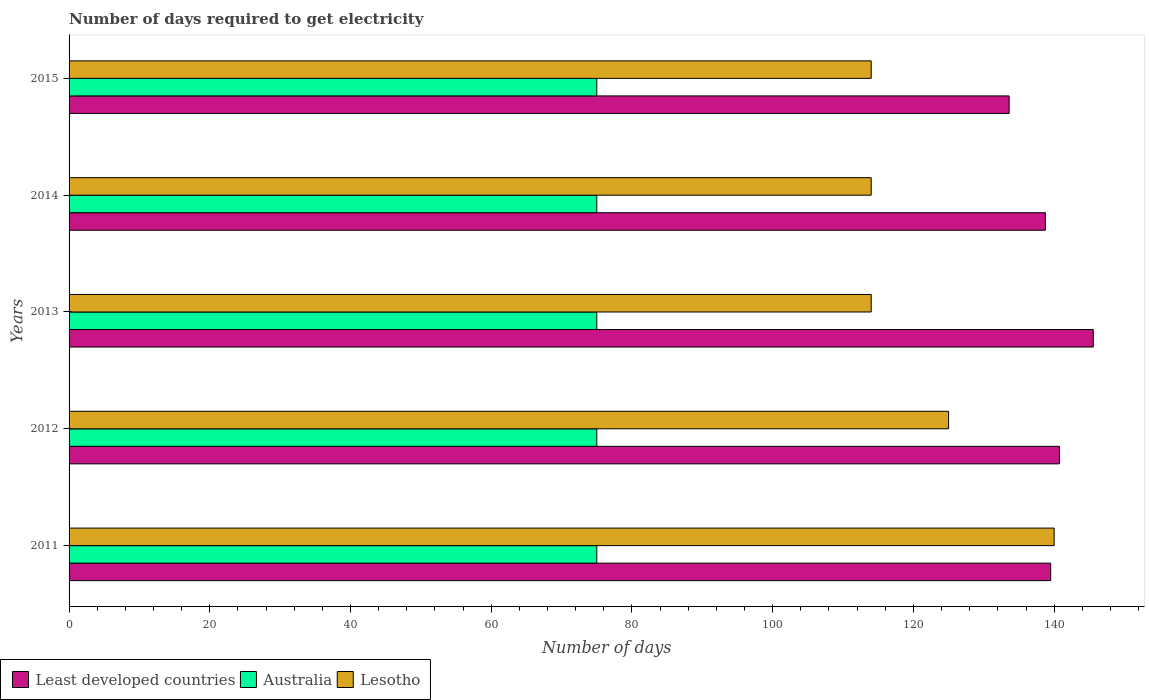How many different coloured bars are there?
Give a very brief answer. 3. Are the number of bars on each tick of the Y-axis equal?
Your response must be concise. Yes. How many bars are there on the 5th tick from the top?
Your answer should be compact. 3. How many bars are there on the 1st tick from the bottom?
Make the answer very short. 3. What is the label of the 4th group of bars from the top?
Keep it short and to the point. 2012. In how many cases, is the number of bars for a given year not equal to the number of legend labels?
Your answer should be very brief. 0. What is the number of days required to get electricity in in Australia in 2014?
Keep it short and to the point. 75. Across all years, what is the maximum number of days required to get electricity in in Lesotho?
Offer a terse response. 140. Across all years, what is the minimum number of days required to get electricity in in Least developed countries?
Your answer should be very brief. 133.61. In which year was the number of days required to get electricity in in Australia maximum?
Give a very brief answer. 2011. In which year was the number of days required to get electricity in in Least developed countries minimum?
Offer a very short reply. 2015. What is the total number of days required to get electricity in in Australia in the graph?
Give a very brief answer. 375. What is the difference between the number of days required to get electricity in in Australia in 2014 and the number of days required to get electricity in in Least developed countries in 2015?
Offer a terse response. -58.61. What is the average number of days required to get electricity in in Australia per year?
Provide a short and direct response. 75. In the year 2015, what is the difference between the number of days required to get electricity in in Australia and number of days required to get electricity in in Least developed countries?
Your answer should be very brief. -58.61. In how many years, is the number of days required to get electricity in in Lesotho greater than 88 days?
Offer a very short reply. 5. What is the difference between the highest and the second highest number of days required to get electricity in in Least developed countries?
Offer a terse response. 4.81. What is the difference between the highest and the lowest number of days required to get electricity in in Lesotho?
Your answer should be compact. 26. In how many years, is the number of days required to get electricity in in Lesotho greater than the average number of days required to get electricity in in Lesotho taken over all years?
Make the answer very short. 2. What does the 3rd bar from the top in 2012 represents?
Make the answer very short. Least developed countries. What does the 1st bar from the bottom in 2012 represents?
Offer a very short reply. Least developed countries. Are all the bars in the graph horizontal?
Give a very brief answer. Yes. What is the difference between two consecutive major ticks on the X-axis?
Give a very brief answer. 20. What is the title of the graph?
Provide a succinct answer. Number of days required to get electricity. What is the label or title of the X-axis?
Ensure brevity in your answer.  Number of days. What is the Number of days in Least developed countries in 2011?
Offer a very short reply. 139.51. What is the Number of days in Australia in 2011?
Offer a very short reply. 75. What is the Number of days in Lesotho in 2011?
Offer a very short reply. 140. What is the Number of days of Least developed countries in 2012?
Offer a terse response. 140.76. What is the Number of days of Australia in 2012?
Your answer should be very brief. 75. What is the Number of days of Lesotho in 2012?
Offer a terse response. 125. What is the Number of days of Least developed countries in 2013?
Provide a short and direct response. 145.56. What is the Number of days of Australia in 2013?
Give a very brief answer. 75. What is the Number of days of Lesotho in 2013?
Provide a succinct answer. 114. What is the Number of days of Least developed countries in 2014?
Offer a very short reply. 138.76. What is the Number of days in Lesotho in 2014?
Offer a terse response. 114. What is the Number of days of Least developed countries in 2015?
Make the answer very short. 133.61. What is the Number of days in Lesotho in 2015?
Provide a succinct answer. 114. Across all years, what is the maximum Number of days in Least developed countries?
Keep it short and to the point. 145.56. Across all years, what is the maximum Number of days of Australia?
Offer a very short reply. 75. Across all years, what is the maximum Number of days of Lesotho?
Provide a short and direct response. 140. Across all years, what is the minimum Number of days in Least developed countries?
Offer a terse response. 133.61. Across all years, what is the minimum Number of days in Lesotho?
Your answer should be very brief. 114. What is the total Number of days in Least developed countries in the graph?
Offer a terse response. 698.2. What is the total Number of days of Australia in the graph?
Your response must be concise. 375. What is the total Number of days in Lesotho in the graph?
Offer a very short reply. 607. What is the difference between the Number of days in Least developed countries in 2011 and that in 2012?
Your answer should be very brief. -1.24. What is the difference between the Number of days in Least developed countries in 2011 and that in 2013?
Provide a succinct answer. -6.05. What is the difference between the Number of days in Least developed countries in 2011 and that in 2014?
Ensure brevity in your answer.  0.75. What is the difference between the Number of days of Australia in 2011 and that in 2014?
Offer a terse response. 0. What is the difference between the Number of days of Least developed countries in 2011 and that in 2015?
Give a very brief answer. 5.91. What is the difference between the Number of days in Lesotho in 2011 and that in 2015?
Your response must be concise. 26. What is the difference between the Number of days in Least developed countries in 2012 and that in 2013?
Keep it short and to the point. -4.81. What is the difference between the Number of days in Australia in 2012 and that in 2013?
Provide a short and direct response. 0. What is the difference between the Number of days of Least developed countries in 2012 and that in 2014?
Your answer should be very brief. 2. What is the difference between the Number of days of Least developed countries in 2012 and that in 2015?
Your response must be concise. 7.15. What is the difference between the Number of days in Australia in 2012 and that in 2015?
Your answer should be compact. 0. What is the difference between the Number of days of Lesotho in 2012 and that in 2015?
Offer a terse response. 11. What is the difference between the Number of days in Least developed countries in 2013 and that in 2014?
Ensure brevity in your answer.  6.8. What is the difference between the Number of days in Lesotho in 2013 and that in 2014?
Give a very brief answer. 0. What is the difference between the Number of days of Least developed countries in 2013 and that in 2015?
Offer a terse response. 11.96. What is the difference between the Number of days of Australia in 2013 and that in 2015?
Keep it short and to the point. 0. What is the difference between the Number of days in Least developed countries in 2014 and that in 2015?
Your answer should be very brief. 5.15. What is the difference between the Number of days in Lesotho in 2014 and that in 2015?
Provide a short and direct response. 0. What is the difference between the Number of days in Least developed countries in 2011 and the Number of days in Australia in 2012?
Give a very brief answer. 64.51. What is the difference between the Number of days of Least developed countries in 2011 and the Number of days of Lesotho in 2012?
Offer a very short reply. 14.51. What is the difference between the Number of days of Least developed countries in 2011 and the Number of days of Australia in 2013?
Offer a very short reply. 64.51. What is the difference between the Number of days of Least developed countries in 2011 and the Number of days of Lesotho in 2013?
Ensure brevity in your answer.  25.51. What is the difference between the Number of days of Australia in 2011 and the Number of days of Lesotho in 2013?
Give a very brief answer. -39. What is the difference between the Number of days in Least developed countries in 2011 and the Number of days in Australia in 2014?
Provide a succinct answer. 64.51. What is the difference between the Number of days of Least developed countries in 2011 and the Number of days of Lesotho in 2014?
Your response must be concise. 25.51. What is the difference between the Number of days in Australia in 2011 and the Number of days in Lesotho in 2014?
Offer a very short reply. -39. What is the difference between the Number of days in Least developed countries in 2011 and the Number of days in Australia in 2015?
Make the answer very short. 64.51. What is the difference between the Number of days of Least developed countries in 2011 and the Number of days of Lesotho in 2015?
Provide a short and direct response. 25.51. What is the difference between the Number of days in Australia in 2011 and the Number of days in Lesotho in 2015?
Provide a short and direct response. -39. What is the difference between the Number of days of Least developed countries in 2012 and the Number of days of Australia in 2013?
Give a very brief answer. 65.76. What is the difference between the Number of days in Least developed countries in 2012 and the Number of days in Lesotho in 2013?
Make the answer very short. 26.76. What is the difference between the Number of days in Australia in 2012 and the Number of days in Lesotho in 2013?
Provide a succinct answer. -39. What is the difference between the Number of days in Least developed countries in 2012 and the Number of days in Australia in 2014?
Provide a succinct answer. 65.76. What is the difference between the Number of days in Least developed countries in 2012 and the Number of days in Lesotho in 2014?
Your answer should be compact. 26.76. What is the difference between the Number of days of Australia in 2012 and the Number of days of Lesotho in 2014?
Provide a short and direct response. -39. What is the difference between the Number of days in Least developed countries in 2012 and the Number of days in Australia in 2015?
Provide a short and direct response. 65.76. What is the difference between the Number of days in Least developed countries in 2012 and the Number of days in Lesotho in 2015?
Provide a short and direct response. 26.76. What is the difference between the Number of days of Australia in 2012 and the Number of days of Lesotho in 2015?
Your answer should be very brief. -39. What is the difference between the Number of days in Least developed countries in 2013 and the Number of days in Australia in 2014?
Provide a short and direct response. 70.56. What is the difference between the Number of days of Least developed countries in 2013 and the Number of days of Lesotho in 2014?
Your answer should be very brief. 31.56. What is the difference between the Number of days in Australia in 2013 and the Number of days in Lesotho in 2014?
Provide a short and direct response. -39. What is the difference between the Number of days of Least developed countries in 2013 and the Number of days of Australia in 2015?
Your response must be concise. 70.56. What is the difference between the Number of days in Least developed countries in 2013 and the Number of days in Lesotho in 2015?
Provide a succinct answer. 31.56. What is the difference between the Number of days in Australia in 2013 and the Number of days in Lesotho in 2015?
Ensure brevity in your answer.  -39. What is the difference between the Number of days of Least developed countries in 2014 and the Number of days of Australia in 2015?
Offer a very short reply. 63.76. What is the difference between the Number of days of Least developed countries in 2014 and the Number of days of Lesotho in 2015?
Offer a very short reply. 24.76. What is the difference between the Number of days of Australia in 2014 and the Number of days of Lesotho in 2015?
Your answer should be compact. -39. What is the average Number of days of Least developed countries per year?
Your answer should be compact. 139.64. What is the average Number of days of Lesotho per year?
Keep it short and to the point. 121.4. In the year 2011, what is the difference between the Number of days of Least developed countries and Number of days of Australia?
Provide a short and direct response. 64.51. In the year 2011, what is the difference between the Number of days in Least developed countries and Number of days in Lesotho?
Give a very brief answer. -0.49. In the year 2011, what is the difference between the Number of days of Australia and Number of days of Lesotho?
Ensure brevity in your answer.  -65. In the year 2012, what is the difference between the Number of days of Least developed countries and Number of days of Australia?
Provide a succinct answer. 65.76. In the year 2012, what is the difference between the Number of days of Least developed countries and Number of days of Lesotho?
Provide a succinct answer. 15.76. In the year 2012, what is the difference between the Number of days of Australia and Number of days of Lesotho?
Offer a terse response. -50. In the year 2013, what is the difference between the Number of days in Least developed countries and Number of days in Australia?
Offer a very short reply. 70.56. In the year 2013, what is the difference between the Number of days in Least developed countries and Number of days in Lesotho?
Keep it short and to the point. 31.56. In the year 2013, what is the difference between the Number of days in Australia and Number of days in Lesotho?
Keep it short and to the point. -39. In the year 2014, what is the difference between the Number of days in Least developed countries and Number of days in Australia?
Ensure brevity in your answer.  63.76. In the year 2014, what is the difference between the Number of days of Least developed countries and Number of days of Lesotho?
Offer a terse response. 24.76. In the year 2014, what is the difference between the Number of days in Australia and Number of days in Lesotho?
Your answer should be compact. -39. In the year 2015, what is the difference between the Number of days of Least developed countries and Number of days of Australia?
Keep it short and to the point. 58.61. In the year 2015, what is the difference between the Number of days in Least developed countries and Number of days in Lesotho?
Your answer should be compact. 19.61. In the year 2015, what is the difference between the Number of days of Australia and Number of days of Lesotho?
Ensure brevity in your answer.  -39. What is the ratio of the Number of days in Australia in 2011 to that in 2012?
Your response must be concise. 1. What is the ratio of the Number of days in Lesotho in 2011 to that in 2012?
Give a very brief answer. 1.12. What is the ratio of the Number of days in Least developed countries in 2011 to that in 2013?
Your answer should be compact. 0.96. What is the ratio of the Number of days of Australia in 2011 to that in 2013?
Offer a very short reply. 1. What is the ratio of the Number of days of Lesotho in 2011 to that in 2013?
Keep it short and to the point. 1.23. What is the ratio of the Number of days of Least developed countries in 2011 to that in 2014?
Give a very brief answer. 1.01. What is the ratio of the Number of days in Lesotho in 2011 to that in 2014?
Provide a short and direct response. 1.23. What is the ratio of the Number of days in Least developed countries in 2011 to that in 2015?
Give a very brief answer. 1.04. What is the ratio of the Number of days in Lesotho in 2011 to that in 2015?
Offer a terse response. 1.23. What is the ratio of the Number of days of Lesotho in 2012 to that in 2013?
Your answer should be very brief. 1.1. What is the ratio of the Number of days in Least developed countries in 2012 to that in 2014?
Your response must be concise. 1.01. What is the ratio of the Number of days of Lesotho in 2012 to that in 2014?
Ensure brevity in your answer.  1.1. What is the ratio of the Number of days of Least developed countries in 2012 to that in 2015?
Your answer should be very brief. 1.05. What is the ratio of the Number of days of Lesotho in 2012 to that in 2015?
Your answer should be very brief. 1.1. What is the ratio of the Number of days of Least developed countries in 2013 to that in 2014?
Your answer should be very brief. 1.05. What is the ratio of the Number of days of Australia in 2013 to that in 2014?
Your response must be concise. 1. What is the ratio of the Number of days in Lesotho in 2013 to that in 2014?
Your response must be concise. 1. What is the ratio of the Number of days of Least developed countries in 2013 to that in 2015?
Your answer should be compact. 1.09. What is the ratio of the Number of days in Lesotho in 2013 to that in 2015?
Ensure brevity in your answer.  1. What is the ratio of the Number of days in Least developed countries in 2014 to that in 2015?
Your answer should be very brief. 1.04. What is the ratio of the Number of days in Australia in 2014 to that in 2015?
Your answer should be very brief. 1. What is the difference between the highest and the second highest Number of days of Least developed countries?
Provide a short and direct response. 4.81. What is the difference between the highest and the second highest Number of days of Australia?
Provide a short and direct response. 0. What is the difference between the highest and the lowest Number of days of Least developed countries?
Offer a very short reply. 11.96. What is the difference between the highest and the lowest Number of days in Lesotho?
Your response must be concise. 26. 